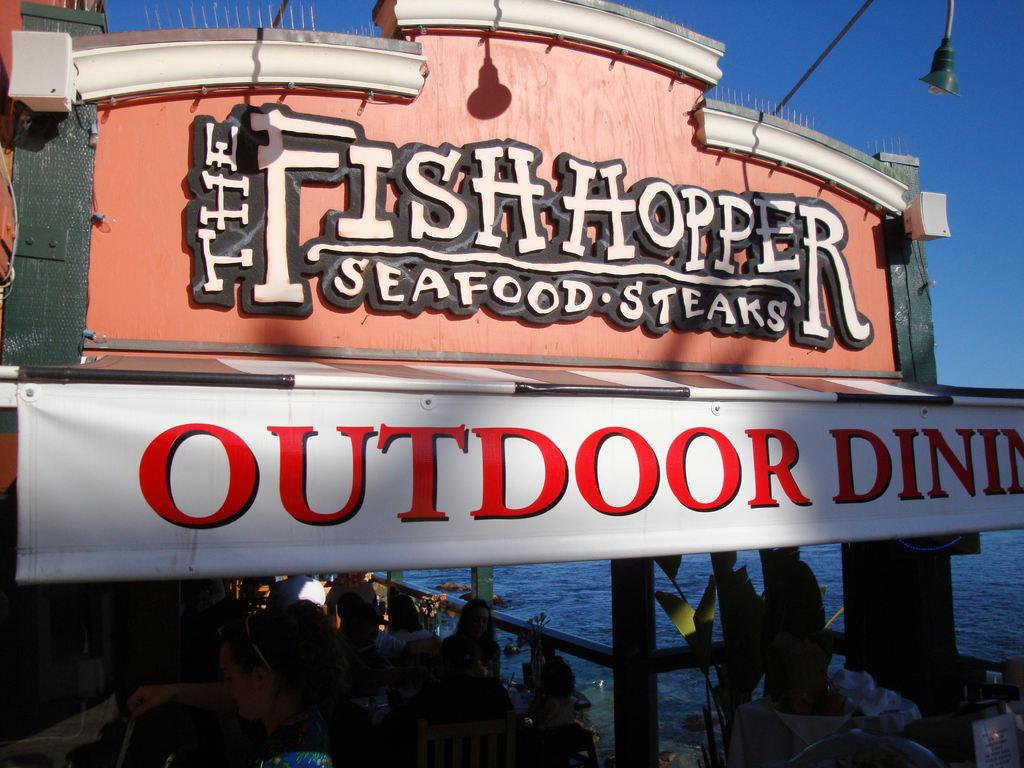What type of structure is present in the image? There is an arch in the image. What is written on the arch? There are words on the arch. What else can be seen in the image besides the arch? There is a banner in the image. What are the people in the image doing? There are people walking in the image. What type of sweater is the clam wearing in the image? There is no clam or sweater present in the image. 